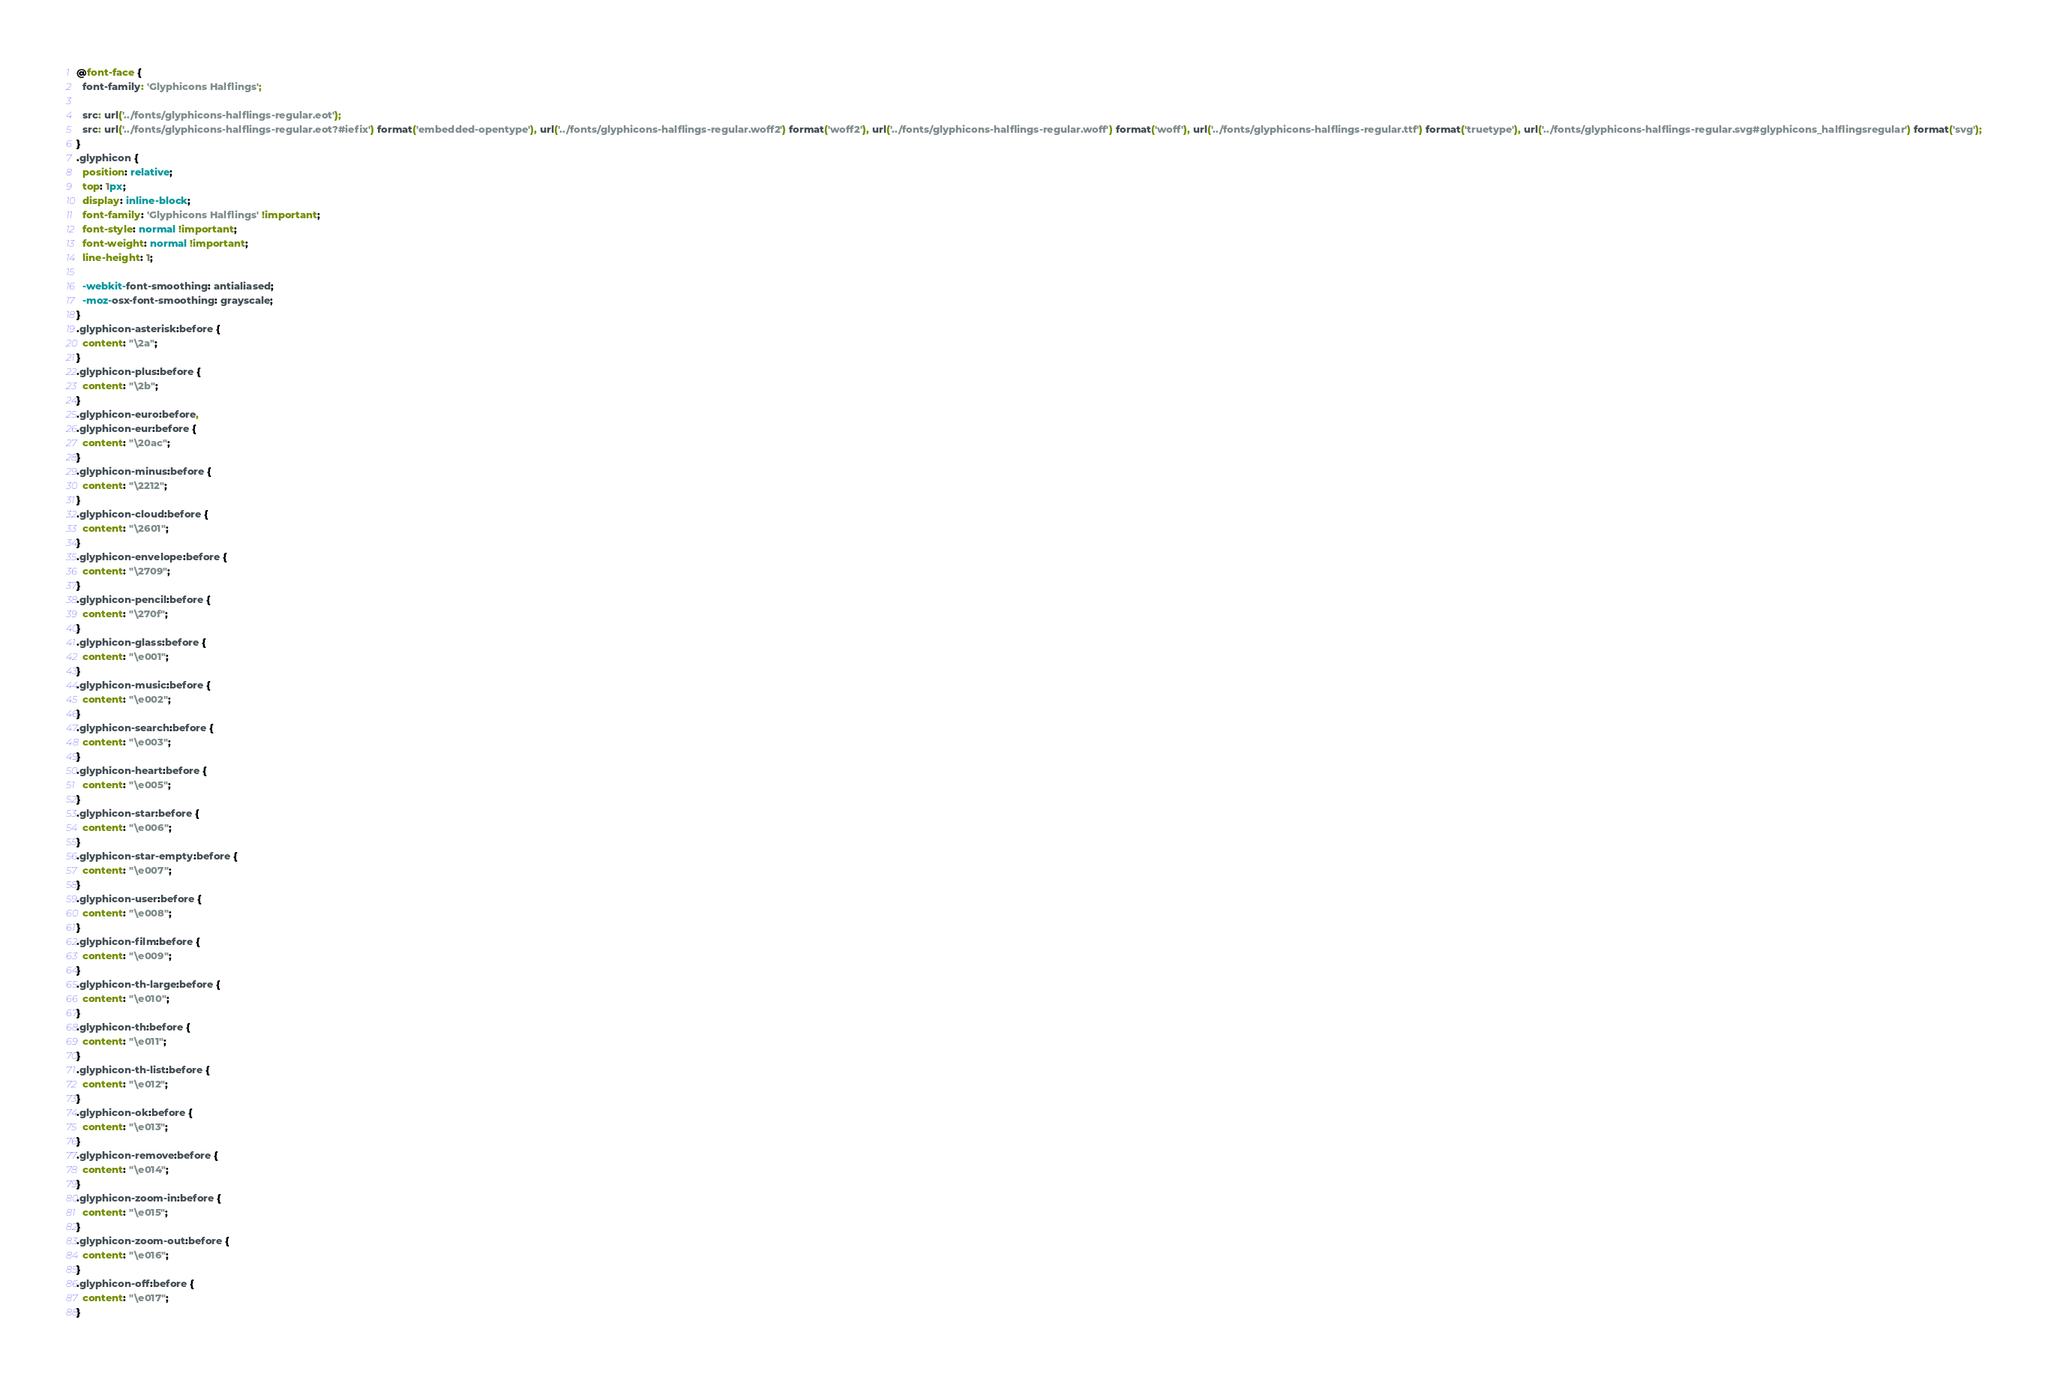Convert code to text. <code><loc_0><loc_0><loc_500><loc_500><_CSS_>
@font-face {
  font-family: 'Glyphicons Halflings';

  src: url('../fonts/glyphicons-halflings-regular.eot');
  src: url('../fonts/glyphicons-halflings-regular.eot?#iefix') format('embedded-opentype'), url('../fonts/glyphicons-halflings-regular.woff2') format('woff2'), url('../fonts/glyphicons-halflings-regular.woff') format('woff'), url('../fonts/glyphicons-halflings-regular.ttf') format('truetype'), url('../fonts/glyphicons-halflings-regular.svg#glyphicons_halflingsregular') format('svg');
}
.glyphicon {
  position: relative;
  top: 1px;
  display: inline-block;
  font-family: 'Glyphicons Halflings' !important;
  font-style: normal !important;
  font-weight: normal !important;
  line-height: 1;

  -webkit-font-smoothing: antialiased;
  -moz-osx-font-smoothing: grayscale;
}
.glyphicon-asterisk:before {
  content: "\2a";
}
.glyphicon-plus:before {
  content: "\2b";
}
.glyphicon-euro:before,
.glyphicon-eur:before {
  content: "\20ac";
}
.glyphicon-minus:before {
  content: "\2212";
}
.glyphicon-cloud:before {
  content: "\2601";
}
.glyphicon-envelope:before {
  content: "\2709";
}
.glyphicon-pencil:before {
  content: "\270f";
}
.glyphicon-glass:before {
  content: "\e001";
}
.glyphicon-music:before {
  content: "\e002";
}
.glyphicon-search:before {
  content: "\e003";
}
.glyphicon-heart:before {
  content: "\e005";
}
.glyphicon-star:before {
  content: "\e006";
}
.glyphicon-star-empty:before {
  content: "\e007";
}
.glyphicon-user:before {
  content: "\e008";
}
.glyphicon-film:before {
  content: "\e009";
}
.glyphicon-th-large:before {
  content: "\e010";
}
.glyphicon-th:before {
  content: "\e011";
}
.glyphicon-th-list:before {
  content: "\e012";
}
.glyphicon-ok:before {
  content: "\e013";
}
.glyphicon-remove:before {
  content: "\e014";
}
.glyphicon-zoom-in:before {
  content: "\e015";
}
.glyphicon-zoom-out:before {
  content: "\e016";
}
.glyphicon-off:before {
  content: "\e017";
}</code> 